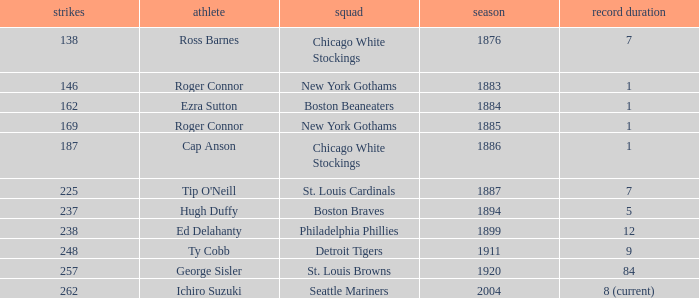Name the player with 238 hits and years after 1885 Ed Delahanty. 